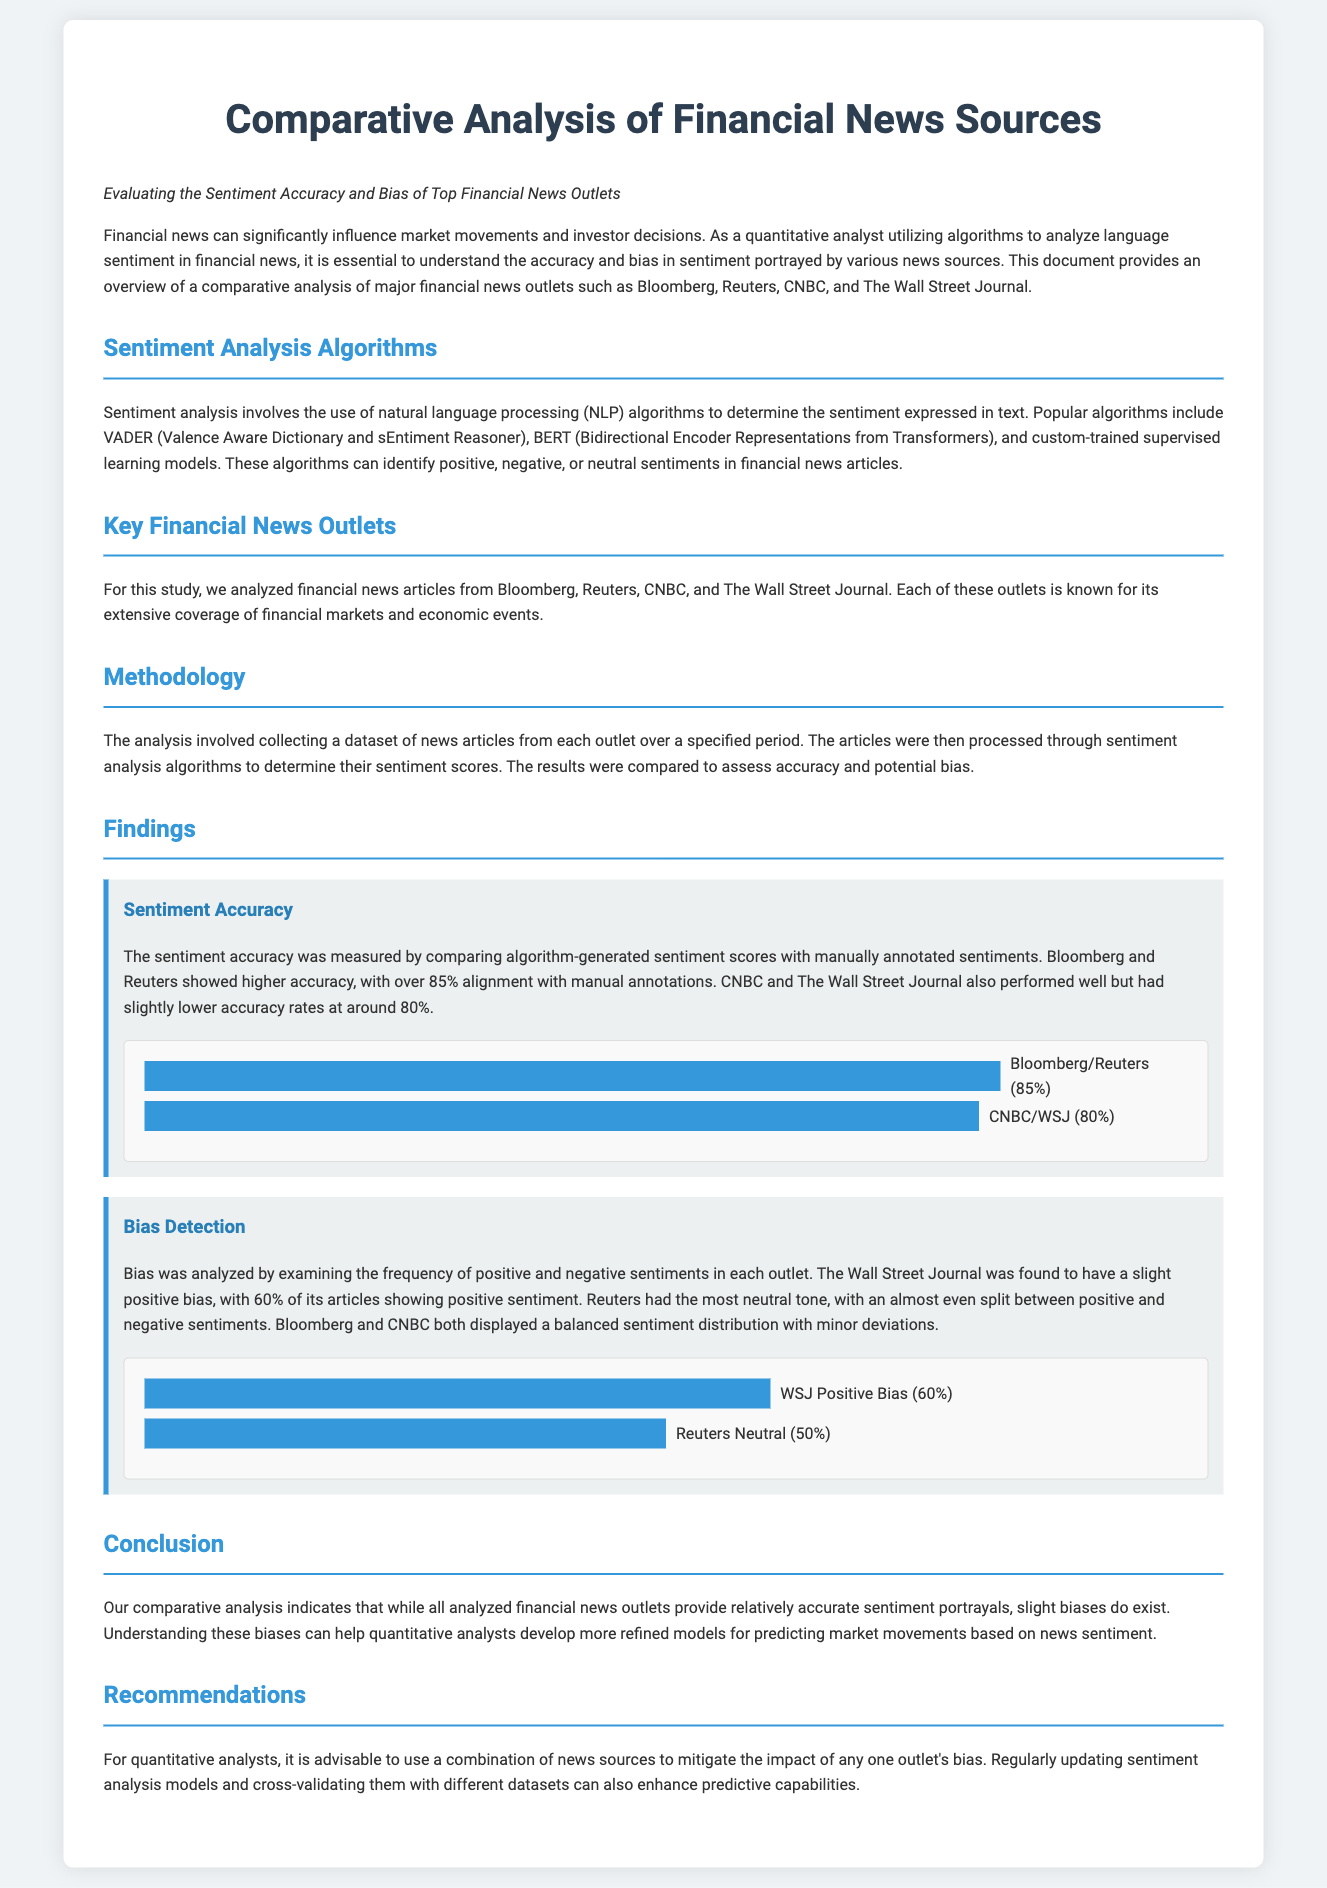what are the names of the financial news outlets analyzed? The document lists the major financial news outlets analyzed in the study as Bloomberg, Reuters, CNBC, and The Wall Street Journal.
Answer: Bloomberg, Reuters, CNBC, The Wall Street Journal what is the sentiment accuracy percentage for Bloomberg and Reuters? The sentiment accuracy for Bloomberg and Reuters is identified as over 85% alignment with manual annotations.
Answer: 85% which outlet has the most neutral tone? The document states that Reuters had the most neutral tone, indicating an almost even split between positive and negative sentiments.
Answer: Reuters what percentage of The Wall Street Journal articles show positive sentiment? The analysis indicated that 60% of The Wall Street Journal articles reflected a positive sentiment.
Answer: 60% what is the recommended approach for quantitative analysts regarding news sources? The document advises quantitative analysts to use a combination of news sources to minimize the impact of bias from any single outlet.
Answer: Combination of news sources 